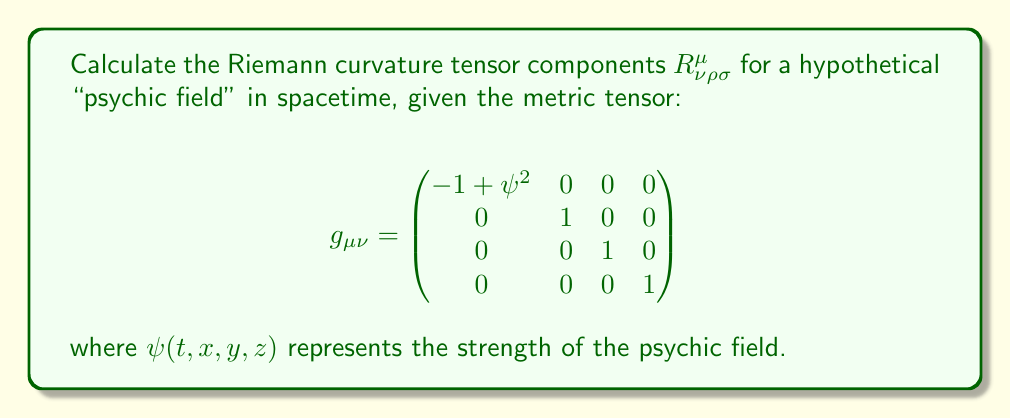Can you solve this math problem? To calculate the Riemann curvature tensor, we'll follow these steps:

1) First, calculate the Christoffel symbols $\Gamma^\mu_{\nu\rho}$:
   $$\Gamma^\mu_{\nu\rho} = \frac{1}{2}g^{\mu\sigma}(\partial_\nu g_{\sigma\rho} + \partial_\rho g_{\sigma\nu} - \partial_\sigma g_{\nu\rho})$$

   The only non-zero components are:
   $$\Gamma^0_{00} = \psi \frac{\partial \psi}{\partial t}$$
   $$\Gamma^0_{0i} = \Gamma^0_{i0} = \psi \frac{\partial \psi}{\partial x^i}$$
   where $i = 1, 2, 3$ correspond to $x, y, z$ respectively.

2) Next, calculate the Riemann tensor using the formula:
   $$R^\mu_{\nu\rho\sigma} = \partial_\rho \Gamma^\mu_{\nu\sigma} - \partial_\sigma \Gamma^\mu_{\nu\rho} + \Gamma^\mu_{\lambda\rho}\Gamma^\lambda_{\nu\sigma} - \Gamma^\mu_{\lambda\sigma}\Gamma^\lambda_{\nu\rho}$$

3) The non-zero components are:
   $$R^0_{i0j} = -R^0_{ij0} = \frac{\partial^2 \psi}{\partial x^i \partial x^j} - \frac{\partial \psi}{\partial x^i} \frac{\partial \psi}{\partial x^j}$$
   where $i, j = 1, 2, 3$ correspond to $x, y, z$.

4) All other components are zero due to the symmetries of the Riemann tensor and the structure of our metric.

5) The full Riemann tensor can be expressed in component form as:
   $$R^\mu_{\nu\rho\sigma} = \delta^0_\mu (\delta^i_\nu \delta^0_\rho \delta^j_\sigma - \delta^i_\nu \delta^j_\rho \delta^0_\sigma) (\frac{\partial^2 \psi}{\partial x^i \partial x^j} - \frac{\partial \psi}{\partial x^i} \frac{\partial \psi}{\partial x^j})$$
   where $\delta^\alpha_\beta$ is the Kronecker delta and $i, j = 1, 2, 3$.
Answer: $$R^\mu_{\nu\rho\sigma} = \delta^0_\mu (\delta^i_\nu \delta^0_\rho \delta^j_\sigma - \delta^i_\nu \delta^j_\rho \delta^0_\sigma) (\frac{\partial^2 \psi}{\partial x^i \partial x^j} - \frac{\partial \psi}{\partial x^i} \frac{\partial \psi}{\partial x^j})$$ 